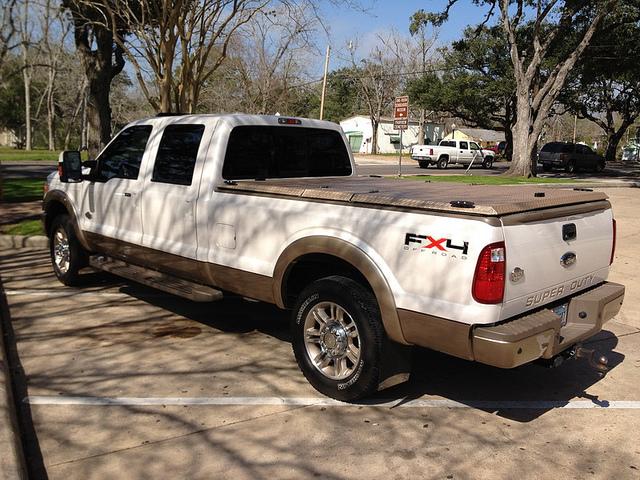How many vehicles in picture are white?
Be succinct. 2. What kind of truck is this?
Write a very short answer. Ford. Can this truck protect items from weather in the pickup portion of the truck?
Answer briefly. Yes. 